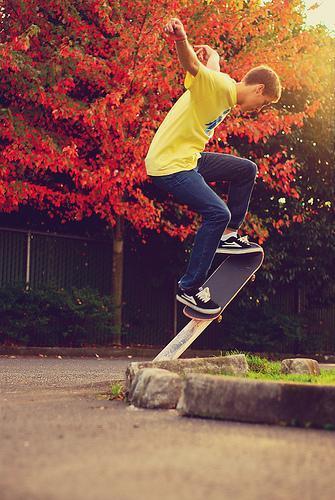How many skateboarders are there?
Give a very brief answer. 1. 